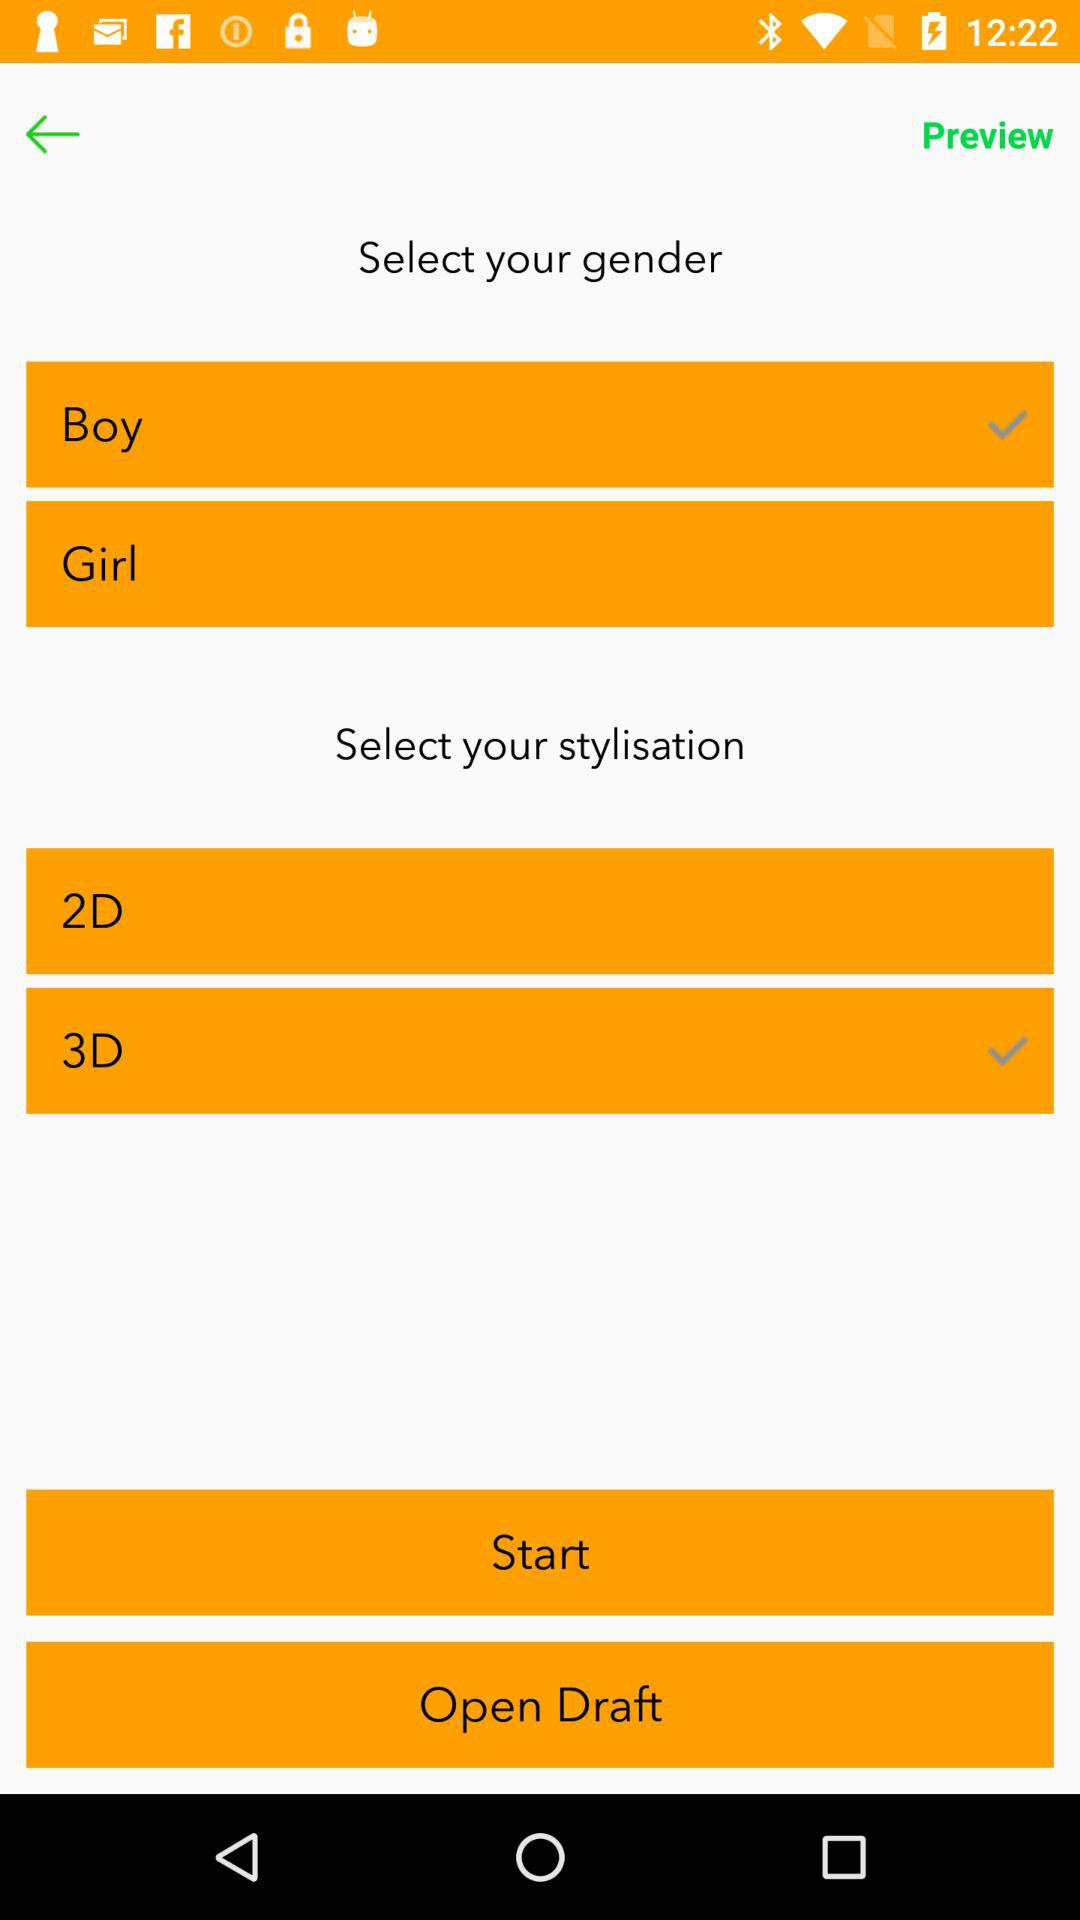What is the username?
When the provided information is insufficient, respond with <no answer>. <no answer> 